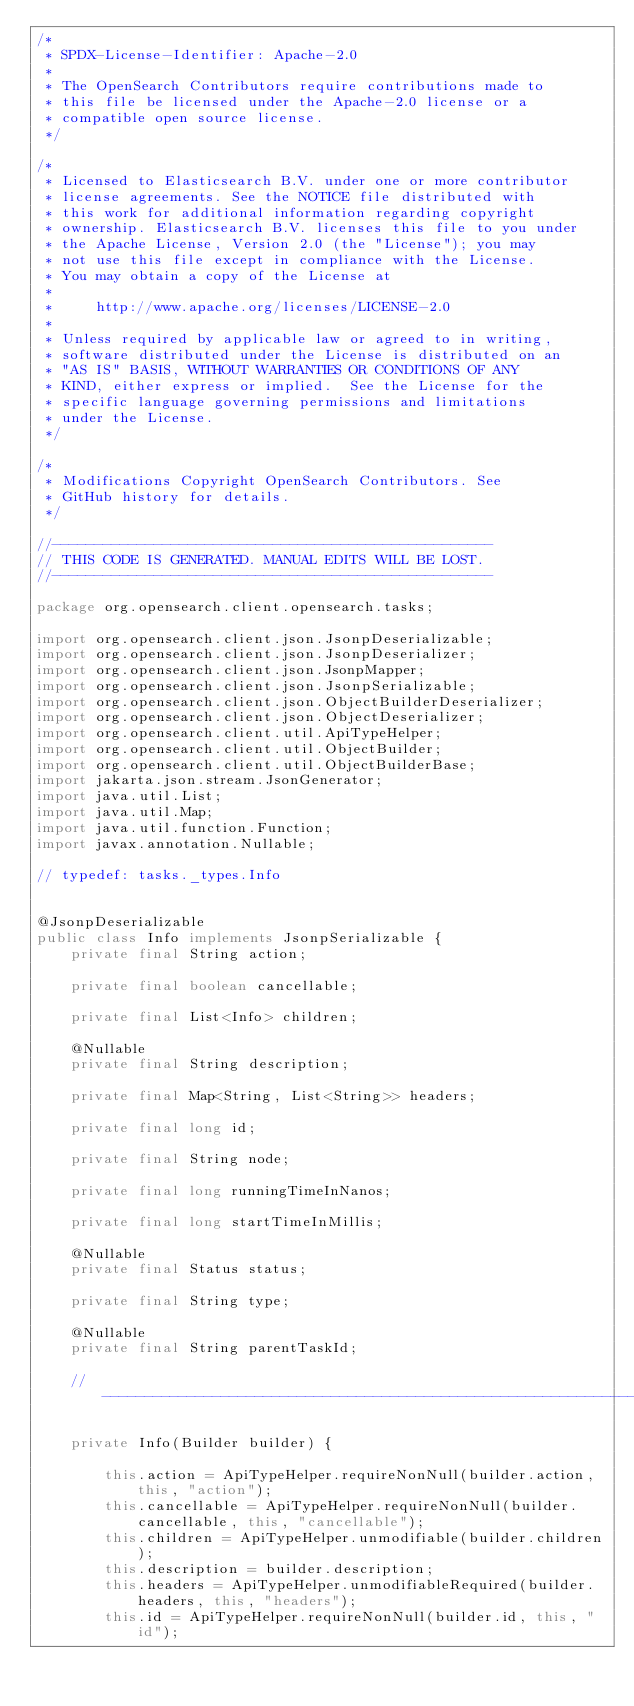Convert code to text. <code><loc_0><loc_0><loc_500><loc_500><_Java_>/*
 * SPDX-License-Identifier: Apache-2.0
 *
 * The OpenSearch Contributors require contributions made to
 * this file be licensed under the Apache-2.0 license or a
 * compatible open source license.
 */

/*
 * Licensed to Elasticsearch B.V. under one or more contributor
 * license agreements. See the NOTICE file distributed with
 * this work for additional information regarding copyright
 * ownership. Elasticsearch B.V. licenses this file to you under
 * the Apache License, Version 2.0 (the "License"); you may
 * not use this file except in compliance with the License.
 * You may obtain a copy of the License at
 *
 *     http://www.apache.org/licenses/LICENSE-2.0
 *
 * Unless required by applicable law or agreed to in writing,
 * software distributed under the License is distributed on an
 * "AS IS" BASIS, WITHOUT WARRANTIES OR CONDITIONS OF ANY
 * KIND, either express or implied.  See the License for the
 * specific language governing permissions and limitations
 * under the License.
 */

/*
 * Modifications Copyright OpenSearch Contributors. See
 * GitHub history for details.
 */

//----------------------------------------------------
// THIS CODE IS GENERATED. MANUAL EDITS WILL BE LOST.
//----------------------------------------------------

package org.opensearch.client.opensearch.tasks;

import org.opensearch.client.json.JsonpDeserializable;
import org.opensearch.client.json.JsonpDeserializer;
import org.opensearch.client.json.JsonpMapper;
import org.opensearch.client.json.JsonpSerializable;
import org.opensearch.client.json.ObjectBuilderDeserializer;
import org.opensearch.client.json.ObjectDeserializer;
import org.opensearch.client.util.ApiTypeHelper;
import org.opensearch.client.util.ObjectBuilder;
import org.opensearch.client.util.ObjectBuilderBase;
import jakarta.json.stream.JsonGenerator;
import java.util.List;
import java.util.Map;
import java.util.function.Function;
import javax.annotation.Nullable;

// typedef: tasks._types.Info


@JsonpDeserializable
public class Info implements JsonpSerializable {
	private final String action;

	private final boolean cancellable;

	private final List<Info> children;

	@Nullable
	private final String description;

	private final Map<String, List<String>> headers;

	private final long id;

	private final String node;

	private final long runningTimeInNanos;

	private final long startTimeInMillis;

	@Nullable
	private final Status status;

	private final String type;

	@Nullable
	private final String parentTaskId;

	// ---------------------------------------------------------------------------------------------

	private Info(Builder builder) {

		this.action = ApiTypeHelper.requireNonNull(builder.action, this, "action");
		this.cancellable = ApiTypeHelper.requireNonNull(builder.cancellable, this, "cancellable");
		this.children = ApiTypeHelper.unmodifiable(builder.children);
		this.description = builder.description;
		this.headers = ApiTypeHelper.unmodifiableRequired(builder.headers, this, "headers");
		this.id = ApiTypeHelper.requireNonNull(builder.id, this, "id");</code> 